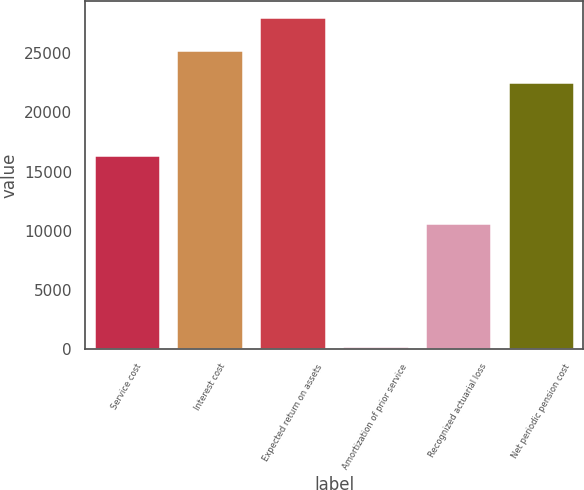<chart> <loc_0><loc_0><loc_500><loc_500><bar_chart><fcel>Service cost<fcel>Interest cost<fcel>Expected return on assets<fcel>Amortization of prior service<fcel>Recognized actuarial loss<fcel>Net periodic pension cost<nl><fcel>16419<fcel>25286.6<fcel>28016.2<fcel>226<fcel>10693<fcel>22557<nl></chart> 